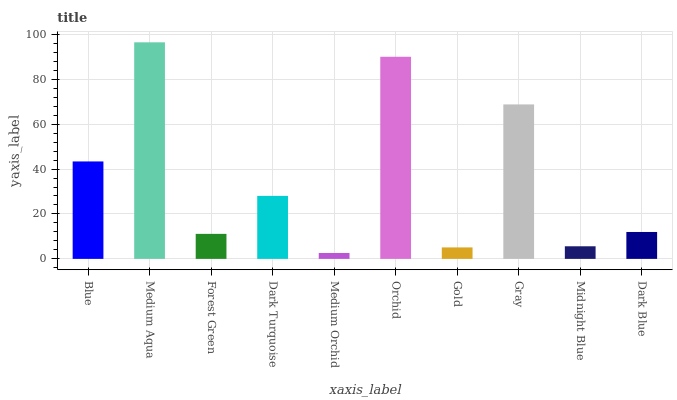Is Medium Orchid the minimum?
Answer yes or no. Yes. Is Medium Aqua the maximum?
Answer yes or no. Yes. Is Forest Green the minimum?
Answer yes or no. No. Is Forest Green the maximum?
Answer yes or no. No. Is Medium Aqua greater than Forest Green?
Answer yes or no. Yes. Is Forest Green less than Medium Aqua?
Answer yes or no. Yes. Is Forest Green greater than Medium Aqua?
Answer yes or no. No. Is Medium Aqua less than Forest Green?
Answer yes or no. No. Is Dark Turquoise the high median?
Answer yes or no. Yes. Is Dark Blue the low median?
Answer yes or no. Yes. Is Blue the high median?
Answer yes or no. No. Is Medium Aqua the low median?
Answer yes or no. No. 